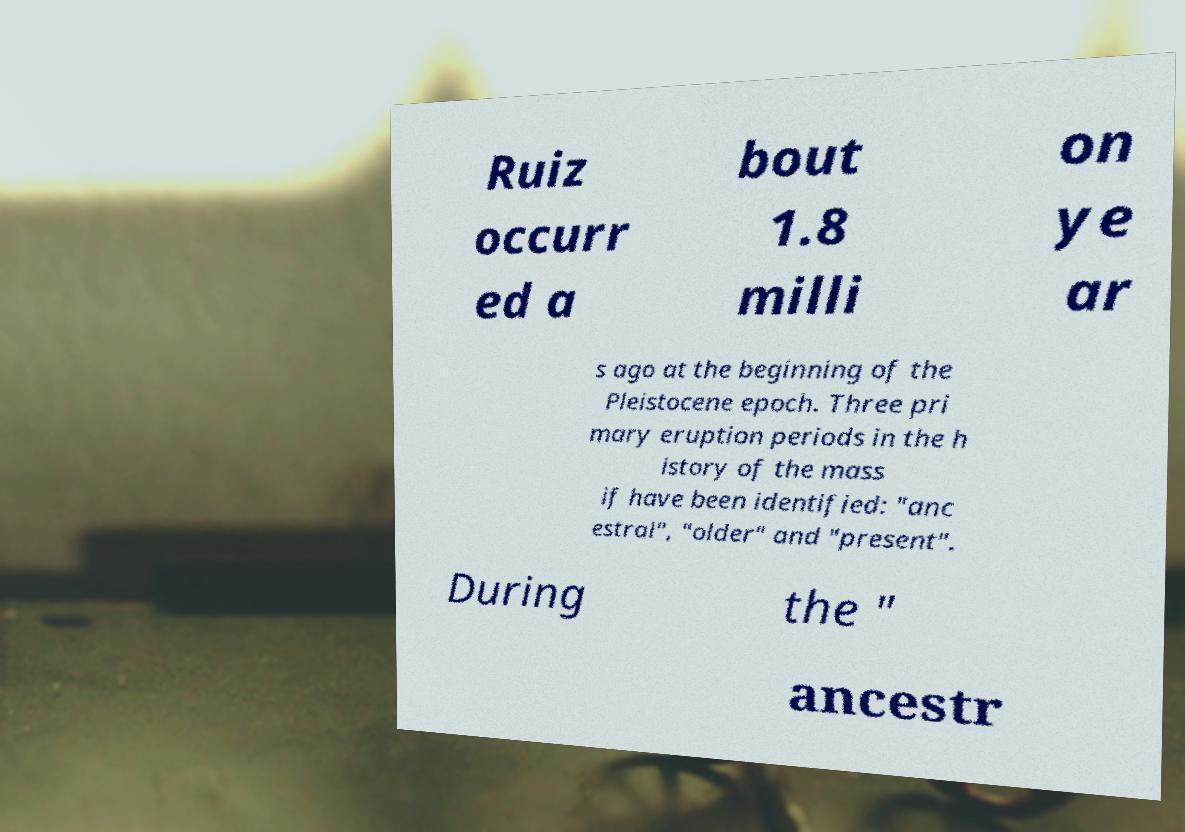Could you extract and type out the text from this image? Ruiz occurr ed a bout 1.8 milli on ye ar s ago at the beginning of the Pleistocene epoch. Three pri mary eruption periods in the h istory of the mass if have been identified: "anc estral", "older" and "present". During the " ancestr 